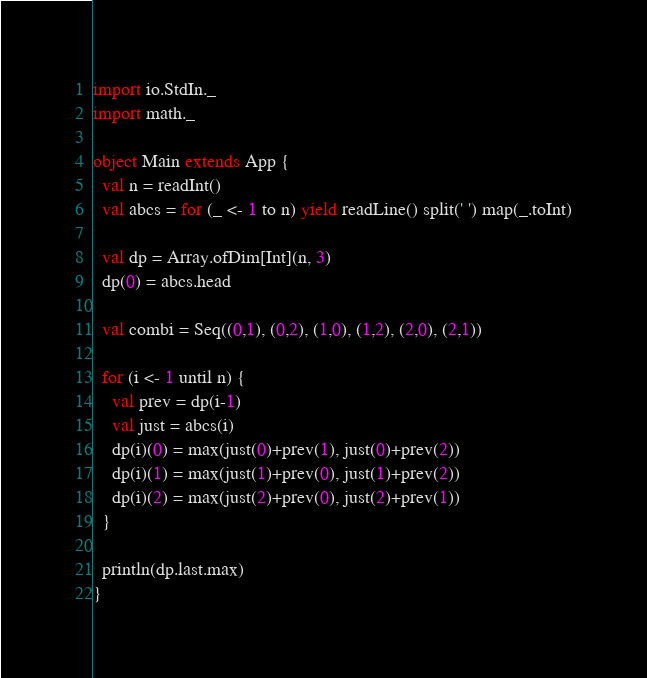Convert code to text. <code><loc_0><loc_0><loc_500><loc_500><_Scala_>import io.StdIn._
import math._

object Main extends App {
  val n = readInt()
  val abcs = for (_ <- 1 to n) yield readLine() split(' ') map(_.toInt)

  val dp = Array.ofDim[Int](n, 3)
  dp(0) = abcs.head

  val combi = Seq((0,1), (0,2), (1,0), (1,2), (2,0), (2,1))

  for (i <- 1 until n) {
    val prev = dp(i-1)
    val just = abcs(i)
    dp(i)(0) = max(just(0)+prev(1), just(0)+prev(2))
    dp(i)(1) = max(just(1)+prev(0), just(1)+prev(2))
    dp(i)(2) = max(just(2)+prev(0), just(2)+prev(1))
  }

  println(dp.last.max)
}</code> 